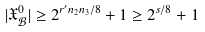Convert formula to latex. <formula><loc_0><loc_0><loc_500><loc_500>| \mathfrak { X } _ { \mathcal { B } } ^ { 0 } | \geq 2 ^ { r ^ { \prime } n _ { 2 } n _ { 3 } / 8 } + 1 \geq 2 ^ { s / 8 } + 1</formula> 